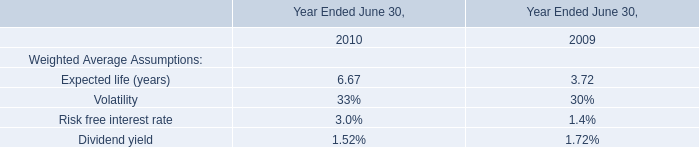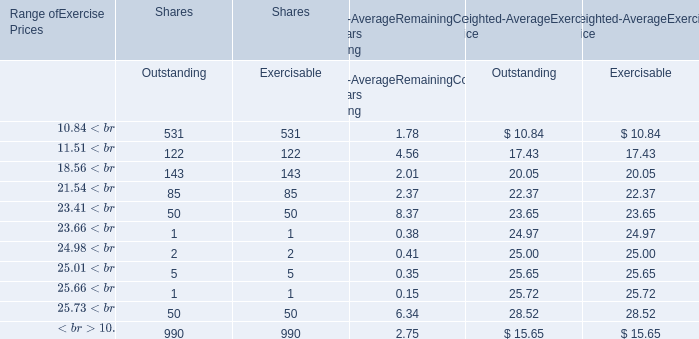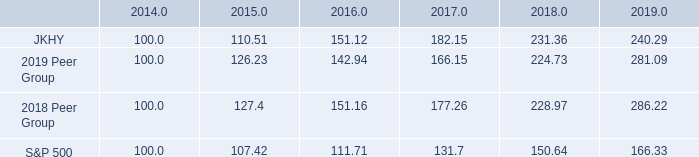What is the proportion of all Exercisable that are greater than 100 to the total amount of Exercisable for Shares? 
Computations: (((531 + 122) + 143) / 990)
Answer: 0.80404. 